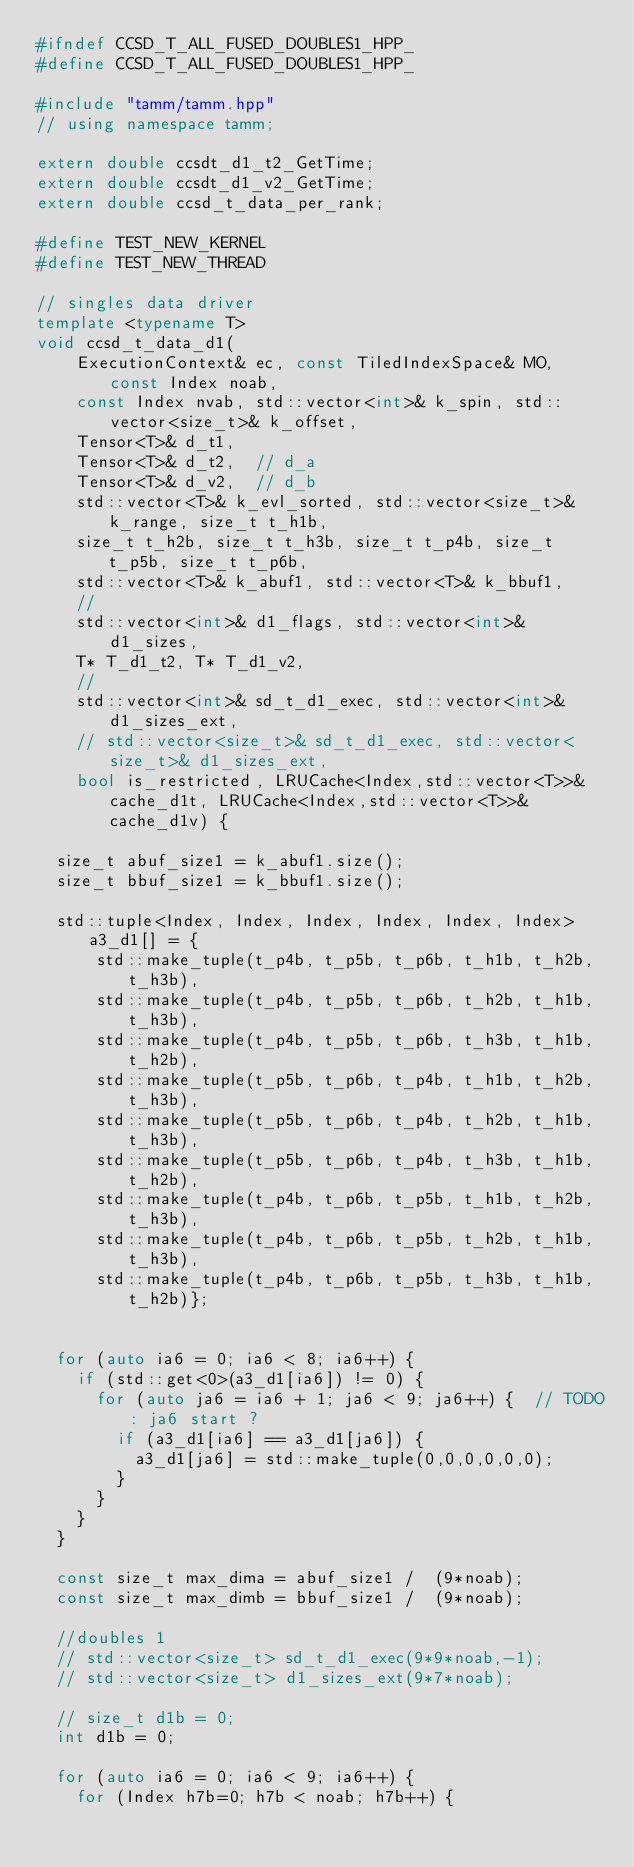Convert code to text. <code><loc_0><loc_0><loc_500><loc_500><_C++_>#ifndef CCSD_T_ALL_FUSED_DOUBLES1_HPP_
#define CCSD_T_ALL_FUSED_DOUBLES1_HPP_

#include "tamm/tamm.hpp"
// using namespace tamm;

extern double ccsdt_d1_t2_GetTime;
extern double ccsdt_d1_v2_GetTime;
extern double ccsd_t_data_per_rank;

#define TEST_NEW_KERNEL
#define TEST_NEW_THREAD

// singles data driver
template <typename T>
void ccsd_t_data_d1(
    ExecutionContext& ec, const TiledIndexSpace& MO, const Index noab,
    const Index nvab, std::vector<int>& k_spin, std::vector<size_t>& k_offset,
    Tensor<T>& d_t1,
    Tensor<T>& d_t2,  // d_a
    Tensor<T>& d_v2,  // d_b
    std::vector<T>& k_evl_sorted, std::vector<size_t>& k_range, size_t t_h1b,
    size_t t_h2b, size_t t_h3b, size_t t_p4b, size_t t_p5b, size_t t_p6b,
    std::vector<T>& k_abuf1, std::vector<T>& k_bbuf1, 
    // 
    std::vector<int>& d1_flags, std::vector<int>& d1_sizes, 
    T* T_d1_t2, T* T_d1_v2, 
    // 
    std::vector<int>& sd_t_d1_exec, std::vector<int>& d1_sizes_ext,
    // std::vector<size_t>& sd_t_d1_exec, std::vector<size_t>& d1_sizes_ext,
    bool is_restricted, LRUCache<Index,std::vector<T>>& cache_d1t, LRUCache<Index,std::vector<T>>& cache_d1v) {

  size_t abuf_size1 = k_abuf1.size();
  size_t bbuf_size1 = k_bbuf1.size();

  std::tuple<Index, Index, Index, Index, Index, Index> a3_d1[] = {
      std::make_tuple(t_p4b, t_p5b, t_p6b, t_h1b, t_h2b, t_h3b),
      std::make_tuple(t_p4b, t_p5b, t_p6b, t_h2b, t_h1b, t_h3b),
      std::make_tuple(t_p4b, t_p5b, t_p6b, t_h3b, t_h1b, t_h2b),
      std::make_tuple(t_p5b, t_p6b, t_p4b, t_h1b, t_h2b, t_h3b),
      std::make_tuple(t_p5b, t_p6b, t_p4b, t_h2b, t_h1b, t_h3b),
      std::make_tuple(t_p5b, t_p6b, t_p4b, t_h3b, t_h1b, t_h2b),
      std::make_tuple(t_p4b, t_p6b, t_p5b, t_h1b, t_h2b, t_h3b),
      std::make_tuple(t_p4b, t_p6b, t_p5b, t_h2b, t_h1b, t_h3b),
      std::make_tuple(t_p4b, t_p6b, t_p5b, t_h3b, t_h1b, t_h2b)};


  for (auto ia6 = 0; ia6 < 8; ia6++) {
    if (std::get<0>(a3_d1[ia6]) != 0) {
      for (auto ja6 = ia6 + 1; ja6 < 9; ja6++) {  // TODO: ja6 start ?
        if (a3_d1[ia6] == a3_d1[ja6]) {
          a3_d1[ja6] = std::make_tuple(0,0,0,0,0,0);
        }
      }
    }
  }

  const size_t max_dima = abuf_size1 /  (9*noab);
  const size_t max_dimb = bbuf_size1 /  (9*noab);

  //doubles 1
  // std::vector<size_t> sd_t_d1_exec(9*9*noab,-1);
  // std::vector<size_t> d1_sizes_ext(9*7*noab);

  // size_t d1b = 0;
  int d1b = 0;

  for (auto ia6 = 0; ia6 < 9; ia6++) {
    for (Index h7b=0; h7b < noab; h7b++) {</code> 